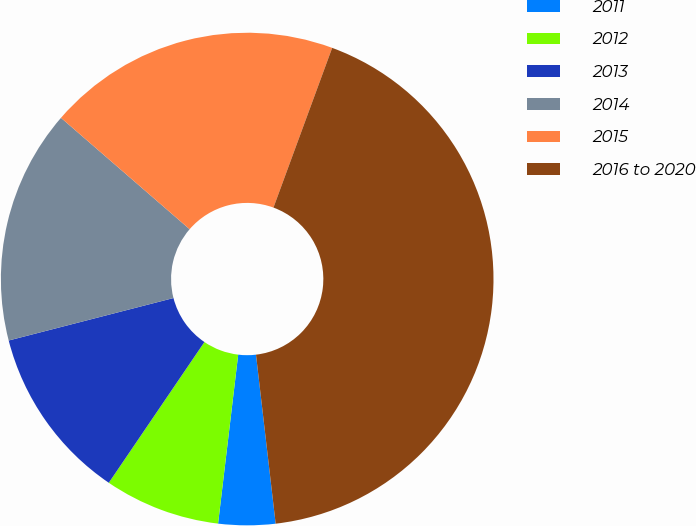Convert chart. <chart><loc_0><loc_0><loc_500><loc_500><pie_chart><fcel>2011<fcel>2012<fcel>2013<fcel>2014<fcel>2015<fcel>2016 to 2020<nl><fcel>3.73%<fcel>7.61%<fcel>11.49%<fcel>15.37%<fcel>19.25%<fcel>42.55%<nl></chart> 